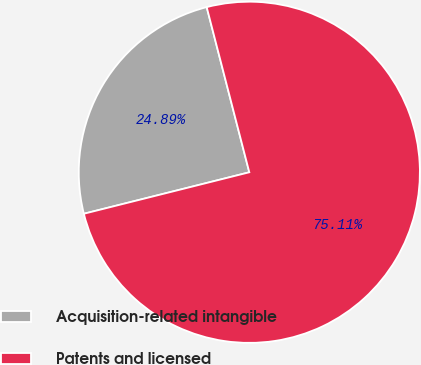Convert chart. <chart><loc_0><loc_0><loc_500><loc_500><pie_chart><fcel>Acquisition-related intangible<fcel>Patents and licensed<nl><fcel>24.89%<fcel>75.11%<nl></chart> 